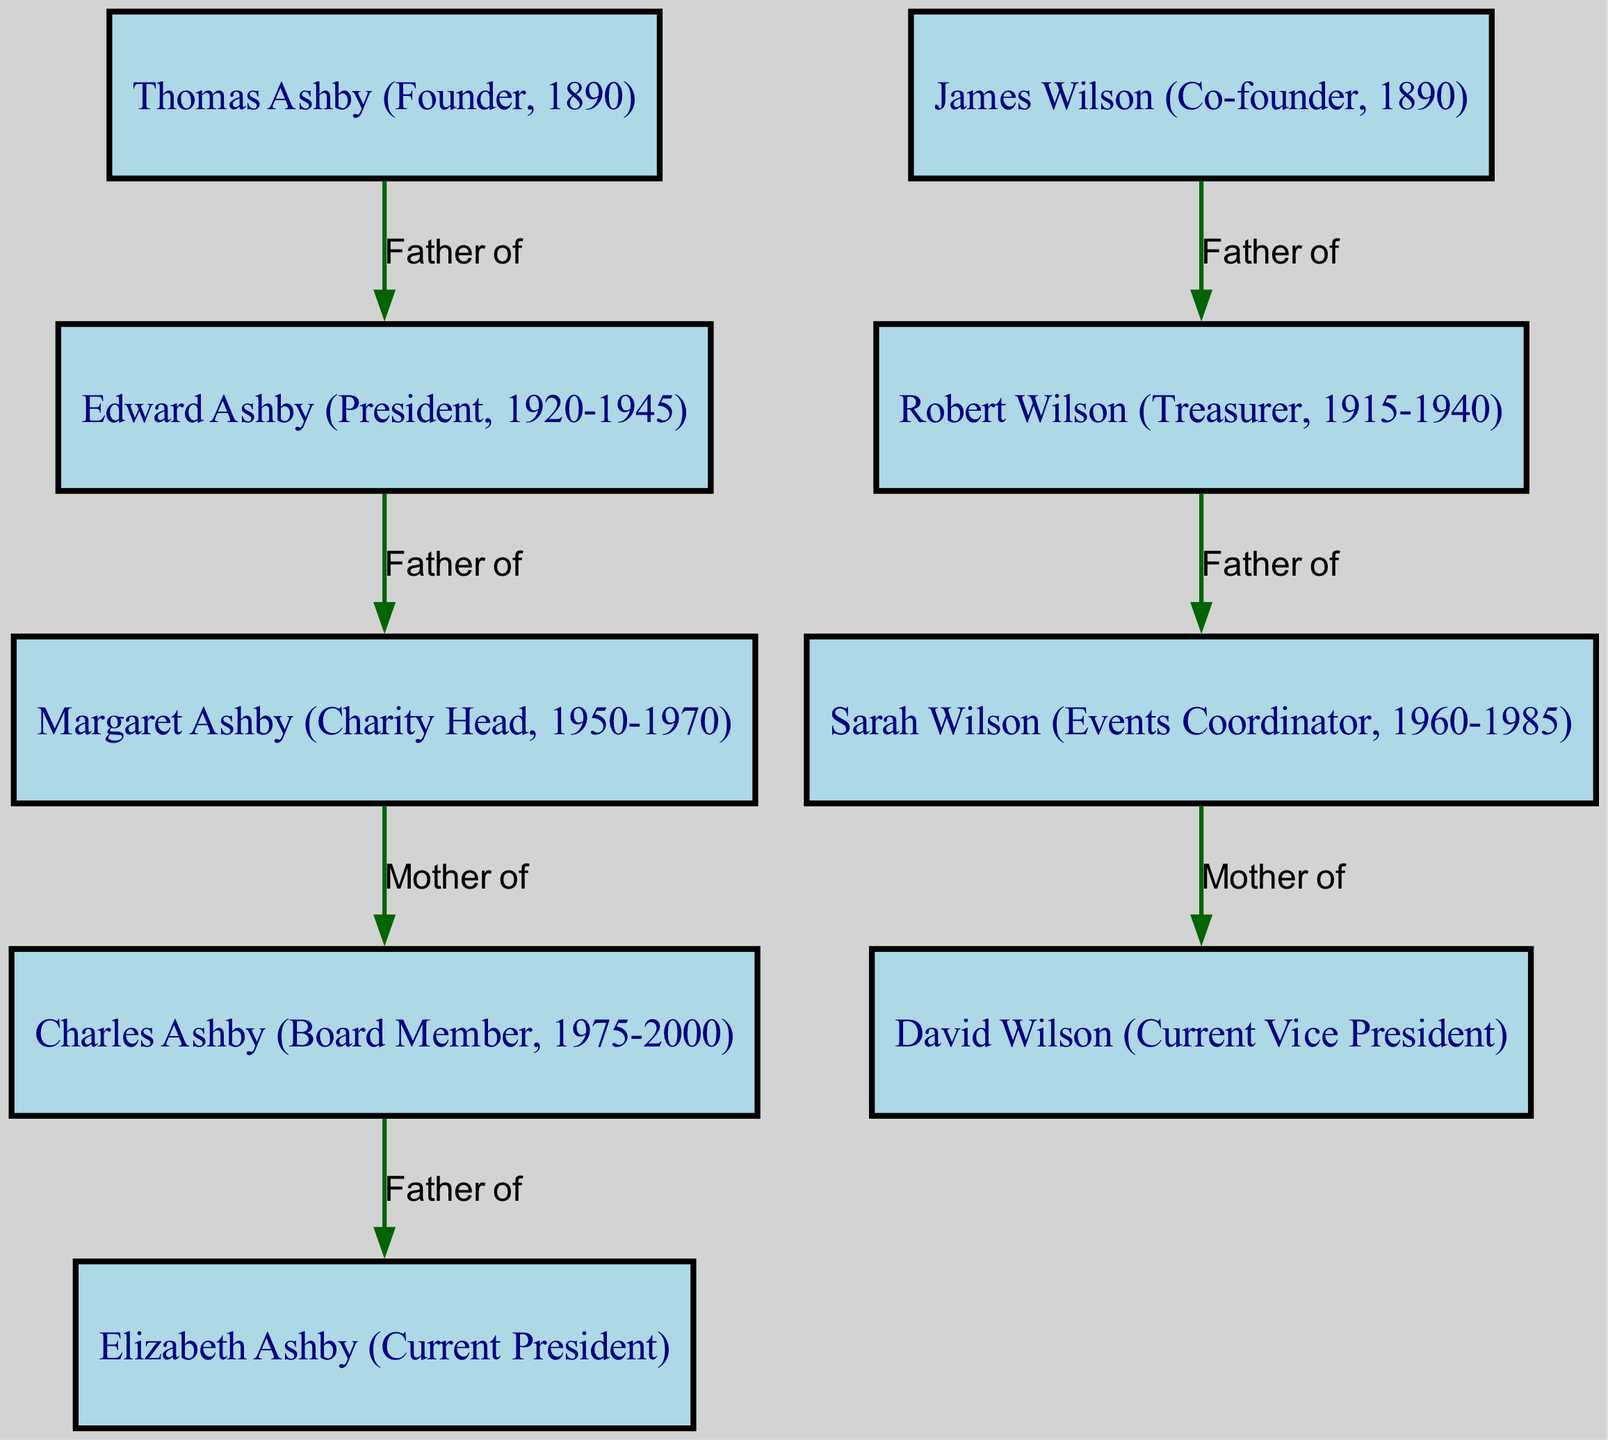What is the relationship between Thomas Ashby and Edward Ashby? The diagram shows an edge labeled "Father of" going from Thomas Ashby to Edward Ashby, indicating that Thomas Ashby is the father of Edward Ashby.
Answer: Father of How many nodes are there in the diagram? By counting the entries in the "nodes" section, we find there are 9 individuals represented.
Answer: 9 Who is the current President of the Empire Club? The node labeled "Elizabeth Ashby (Current President)" clearly indicates that Elizabeth Ashby holds this position.
Answer: Elizabeth Ashby How is David Wilson related to Robert Wilson? Analyzing the edges, it shows that Robert Wilson is connected by the label "Father of" to Sarah Wilson, who is in turn connected by "Mother of" to David Wilson, meaning Robert Wilson is David Wilson's grandfather.
Answer: Grandfather What role did Margaret Ashby hold from 1950 to 1970? The diagram directly states her role as "Charity Head" during this period, as indicated in the node label.
Answer: Charity Head Which founder of the club had a direct descent leading to the current Vice President? Tracing the edges from James Wilson to Robert Wilson, then to Sarah Wilson, and finally to David Wilson, it is clear that David Wilson is a direct descendant of James Wilson.
Answer: James Wilson What is the total number of edges in the diagram? The reasons consist of counting the connections listed in the "edges" section of the diagram. There are 7 connections shown.
Answer: 7 Who is the mother of Charles Ashby? The edge labeled "Mother of" going from Margaret Ashby to Charles Ashby indicates that Margaret Ashby is his mother.
Answer: Margaret Ashby Which descendant ties both founding families together? Analyzing the relationships, we see that Elizabeth Ashby, a descendant of Thomas Ashby, and David Wilson, a descendant of James Wilson, are connected through their parentage, making them relatives.
Answer: Elizabeth Ashby and David Wilson 